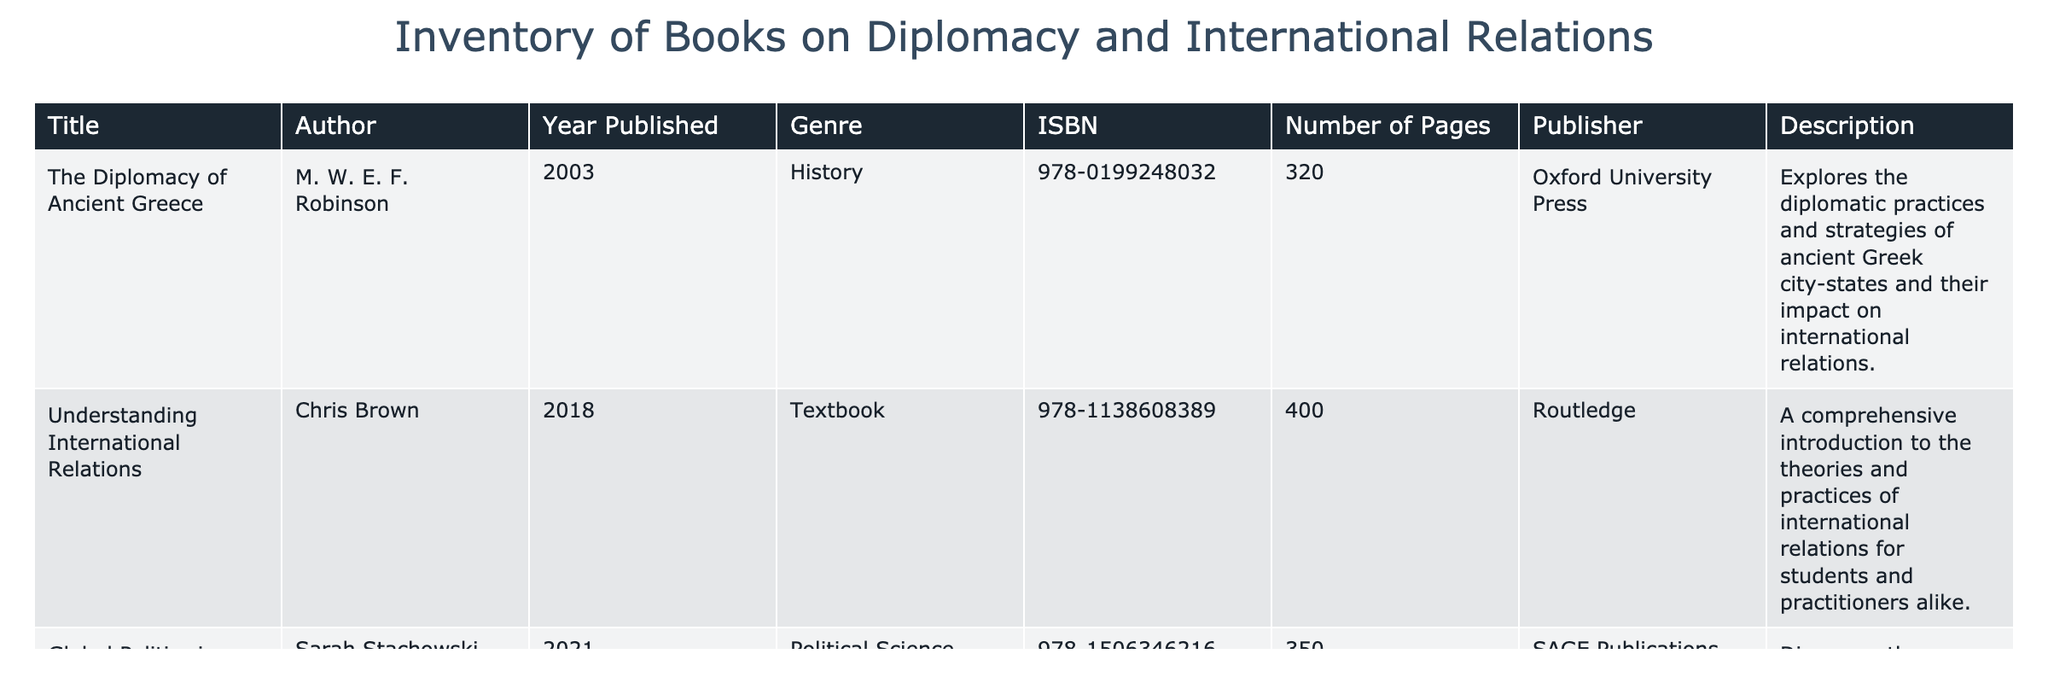What is the title of the book authored by Chris Brown? The table shows a column for the title of the books along with their authors. By looking up the entry for Chris Brown under the Author column, we can find that the title associated with him is "Understanding International Relations."
Answer: Understanding International Relations Which book has the highest number of pages? To determine the book with the highest number of pages, I need to compare the "Number of Pages" column. The values are 320, 400, 350, 200, and 672. The highest value is 672, which corresponds to "Politics Among Nations: The Struggle for Power and Peace" by Hans J. Morgenthau.
Answer: Politics Among Nations: The Struggle for Power and Peace Is "The Art of Diplomacy: Strengthening Relationships" published by SAGE Publications? The table lists the publishers for each book in the Publisher column. Looking at the entry for "The Art of Diplomacy: Strengthening Relationships," its publisher is Chronicle Books. Thus, the statement is false.
Answer: No How many books are there written on political science? The table has a column for Genre. We will count how many books fall under the "Political Science" category. There are two books listed with the political science genre: "Global Politics in a Changing World." Therefore, the count is one.
Answer: 1 What is the average number of pages across all books in the inventory? To find the average, I must sum the number of pages in each book: 320 + 400 + 350 + 200 + 672 = 1942. Then, I divide that total by the number of books, which is 5. Thus, 1942 divided by 5 equals 388.4.
Answer: 388.4 Which book discusses ancient Greece's diplomacy? The title "The Diplomacy of Ancient Greece" clearly indicates that it focuses on the ancient Greek city-states' diplomatic practices. The title and author column confirm it is authored by M. W. E. F. Robinson.
Answer: The Diplomacy of Ancient Greece Does the inventory include books that were published after 2015? By scanning the "Year Published" column, I see the years 2018, 2021, and 2019, which are all after 2015. Therefore, the answer to whether books published after 2015 exist in this inventory is yes.
Answer: Yes How many books are written by authors whose name starts with "S"? The table lists three authors: M. W. E. F. Robinson, Chris Brown, Sarah Stachowski, James W. Wilkins, and Hans J. Morgenthau. We find that only one author, Sarah Stachowski, starts with "S," therefore the count is one.
Answer: 1 